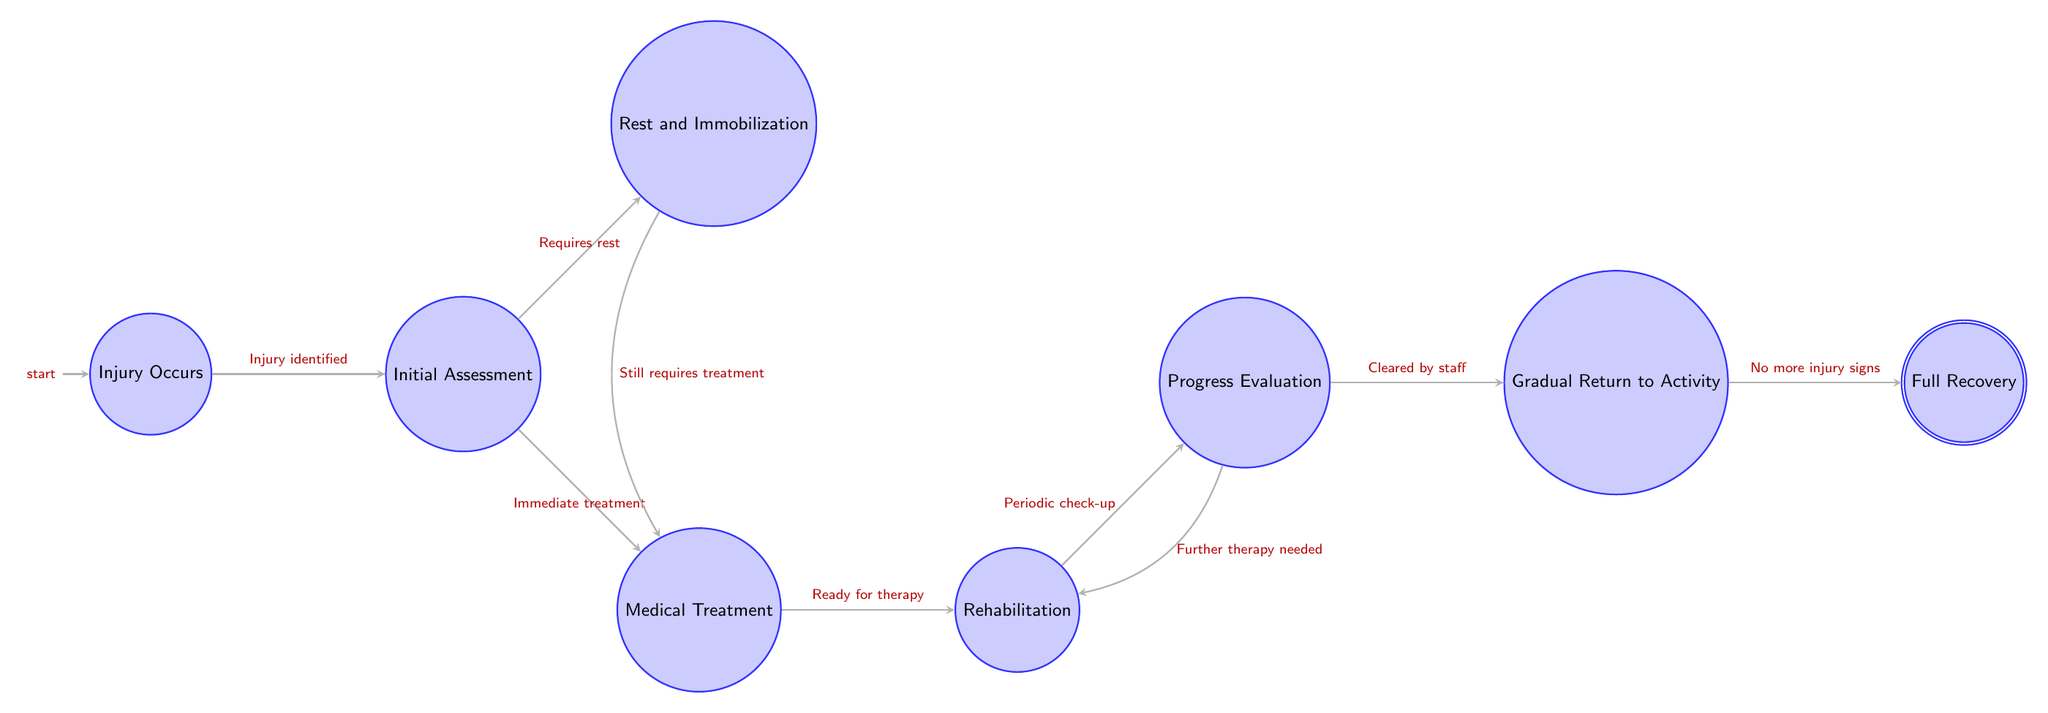What's the first state in the diagram? The first state, marked as the initial node, is "Injury Occurs" which indicates the beginning of the injury recovery process.
Answer: Injury Occurs How many states are there in total? Counting all the states listed in the diagram: "Injury Occurs," "Initial Assessment," "Rest and Immobilization," "Medical Treatment," "Rehabilitation," "Progress Evaluation," "Gradual Return to Activity," and "Full Recovery," there are 8 states.
Answer: 8 What transition follows "Medical Treatment"? From "Medical Treatment," the next transition leads to "Rehabilitation," which indicates that the next step after treatment is to engage in rehabilitation.
Answer: Rehabilitation What event triggers the transition from "Initial Assessment" to "Rest and Immobilization"? The transition from "Initial Assessment" to "Rest and Immobilization" is triggered by the condition "Injury severity requires rest," which means the assessment leads to rest based on the injury's severity.
Answer: Injury severity requires rest What state requires a periodic check-up? The state "Rehabilitation" requires a periodic check-up before moving to "Progress Evaluation," indicating that regular assessments are part of the rehabilitation process.
Answer: Rehabilitation If an athlete is cleared by medical staff, which state do they move to next? Upon being cleared by medical staff during the "Progress Evaluation," the next state they transition to is "Gradual Return to Activity," marking the beginning of their reintroduction to training.
Answer: Gradual Return to Activity In which state does the athlete start physical therapy? The athlete begins physical therapy in the "Rehabilitation" state, which follows the "Medical Treatment" stage where they are prepared for therapy.
Answer: Rehabilitation What is the condition to transition from "Progress Evaluation" back to "Rehabilitation"? The transition from "Progress Evaluation" back to "Rehabilitation" occurs if "Further therapy needed," indicating that additional therapy is required after evaluation.
Answer: Further therapy needed What condition marks the end of the recovery process? The end of the recovery process is marked by the condition "No more injury signs," leading the athlete from "Gradual Return to Activity" to "Full Recovery."
Answer: No more injury signs 